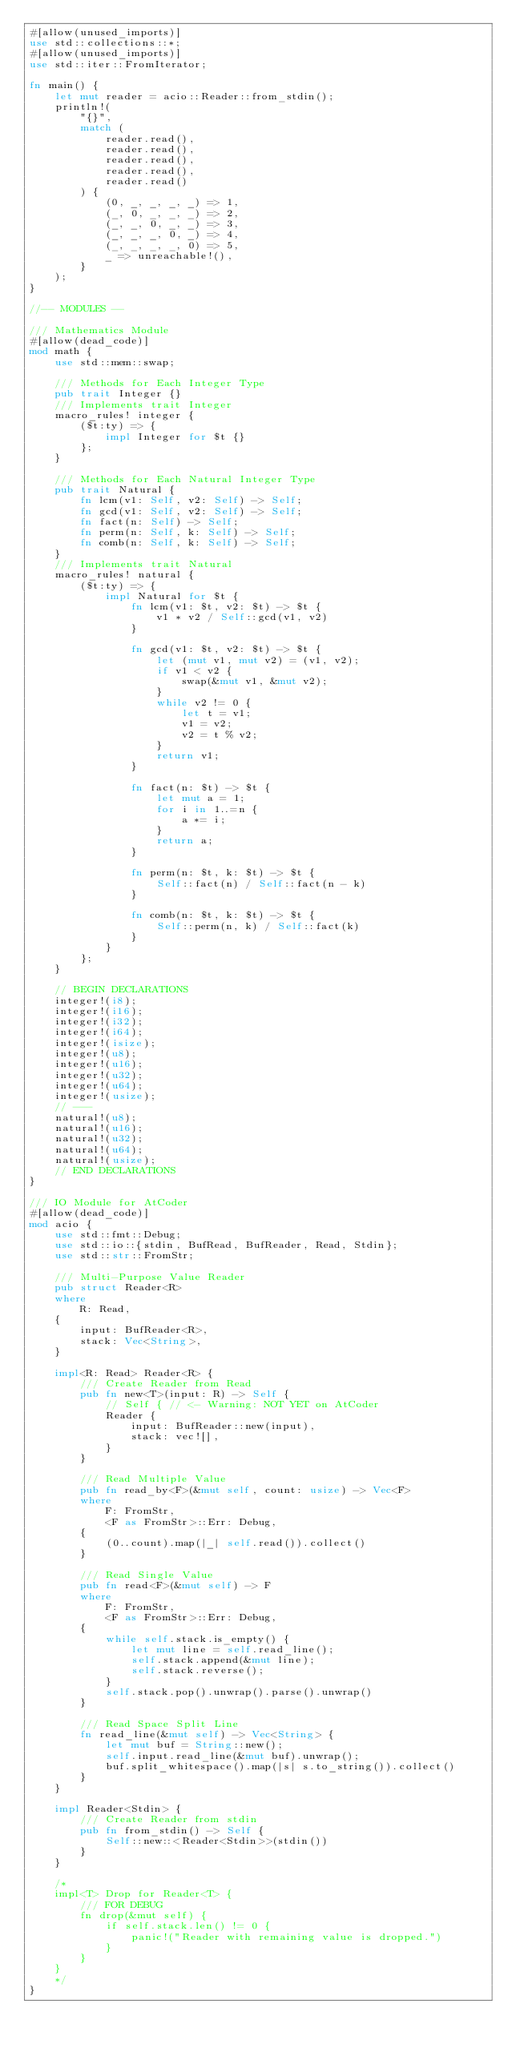Convert code to text. <code><loc_0><loc_0><loc_500><loc_500><_Rust_>#[allow(unused_imports)]
use std::collections::*;
#[allow(unused_imports)]
use std::iter::FromIterator;

fn main() {
    let mut reader = acio::Reader::from_stdin();
    println!(
        "{}",
        match (
            reader.read(),
            reader.read(),
            reader.read(),
            reader.read(),
            reader.read()
        ) {
            (0, _, _, _, _) => 1,
            (_, 0, _, _, _) => 2,
            (_, _, 0, _, _) => 3,
            (_, _, _, 0, _) => 4,
            (_, _, _, _, 0) => 5,
            _ => unreachable!(),
        }
    );
}

//-- MODULES --

/// Mathematics Module
#[allow(dead_code)]
mod math {
    use std::mem::swap;

    /// Methods for Each Integer Type
    pub trait Integer {}
    /// Implements trait Integer
    macro_rules! integer {
        ($t:ty) => {
            impl Integer for $t {}
        };
    }

    /// Methods for Each Natural Integer Type
    pub trait Natural {
        fn lcm(v1: Self, v2: Self) -> Self;
        fn gcd(v1: Self, v2: Self) -> Self;
        fn fact(n: Self) -> Self;
        fn perm(n: Self, k: Self) -> Self;
        fn comb(n: Self, k: Self) -> Self;
    }
    /// Implements trait Natural
    macro_rules! natural {
        ($t:ty) => {
            impl Natural for $t {
                fn lcm(v1: $t, v2: $t) -> $t {
                    v1 * v2 / Self::gcd(v1, v2)
                }

                fn gcd(v1: $t, v2: $t) -> $t {
                    let (mut v1, mut v2) = (v1, v2);
                    if v1 < v2 {
                        swap(&mut v1, &mut v2);
                    }
                    while v2 != 0 {
                        let t = v1;
                        v1 = v2;
                        v2 = t % v2;
                    }
                    return v1;
                }

                fn fact(n: $t) -> $t {
                    let mut a = 1;
                    for i in 1..=n {
                        a *= i;
                    }
                    return a;
                }

                fn perm(n: $t, k: $t) -> $t {
                    Self::fact(n) / Self::fact(n - k)
                }

                fn comb(n: $t, k: $t) -> $t {
                    Self::perm(n, k) / Self::fact(k)
                }
            }
        };
    }

    // BEGIN DECLARATIONS
    integer!(i8);
    integer!(i16);
    integer!(i32);
    integer!(i64);
    integer!(isize);
    integer!(u8);
    integer!(u16);
    integer!(u32);
    integer!(u64);
    integer!(usize);
    // ---
    natural!(u8);
    natural!(u16);
    natural!(u32);
    natural!(u64);
    natural!(usize);
    // END DECLARATIONS
}

/// IO Module for AtCoder
#[allow(dead_code)]
mod acio {
    use std::fmt::Debug;
    use std::io::{stdin, BufRead, BufReader, Read, Stdin};
    use std::str::FromStr;

    /// Multi-Purpose Value Reader
    pub struct Reader<R>
    where
        R: Read,
    {
        input: BufReader<R>,
        stack: Vec<String>,
    }

    impl<R: Read> Reader<R> {
        /// Create Reader from Read
        pub fn new<T>(input: R) -> Self {
            // Self { // <- Warning: NOT YET on AtCoder
            Reader {
                input: BufReader::new(input),
                stack: vec![],
            }
        }

        /// Read Multiple Value
        pub fn read_by<F>(&mut self, count: usize) -> Vec<F>
        where
            F: FromStr,
            <F as FromStr>::Err: Debug,
        {
            (0..count).map(|_| self.read()).collect()
        }

        /// Read Single Value
        pub fn read<F>(&mut self) -> F
        where
            F: FromStr,
            <F as FromStr>::Err: Debug,
        {
            while self.stack.is_empty() {
                let mut line = self.read_line();
                self.stack.append(&mut line);
                self.stack.reverse();
            }
            self.stack.pop().unwrap().parse().unwrap()
        }

        /// Read Space Split Line
        fn read_line(&mut self) -> Vec<String> {
            let mut buf = String::new();
            self.input.read_line(&mut buf).unwrap();
            buf.split_whitespace().map(|s| s.to_string()).collect()
        }
    }

    impl Reader<Stdin> {
        /// Create Reader from stdin
        pub fn from_stdin() -> Self {
            Self::new::<Reader<Stdin>>(stdin())
        }
    }

    /*
    impl<T> Drop for Reader<T> {
        /// FOR DEBUG
        fn drop(&mut self) {
            if self.stack.len() != 0 {
                panic!("Reader with remaining value is dropped.")
            }
        }
    }
    */
}
</code> 